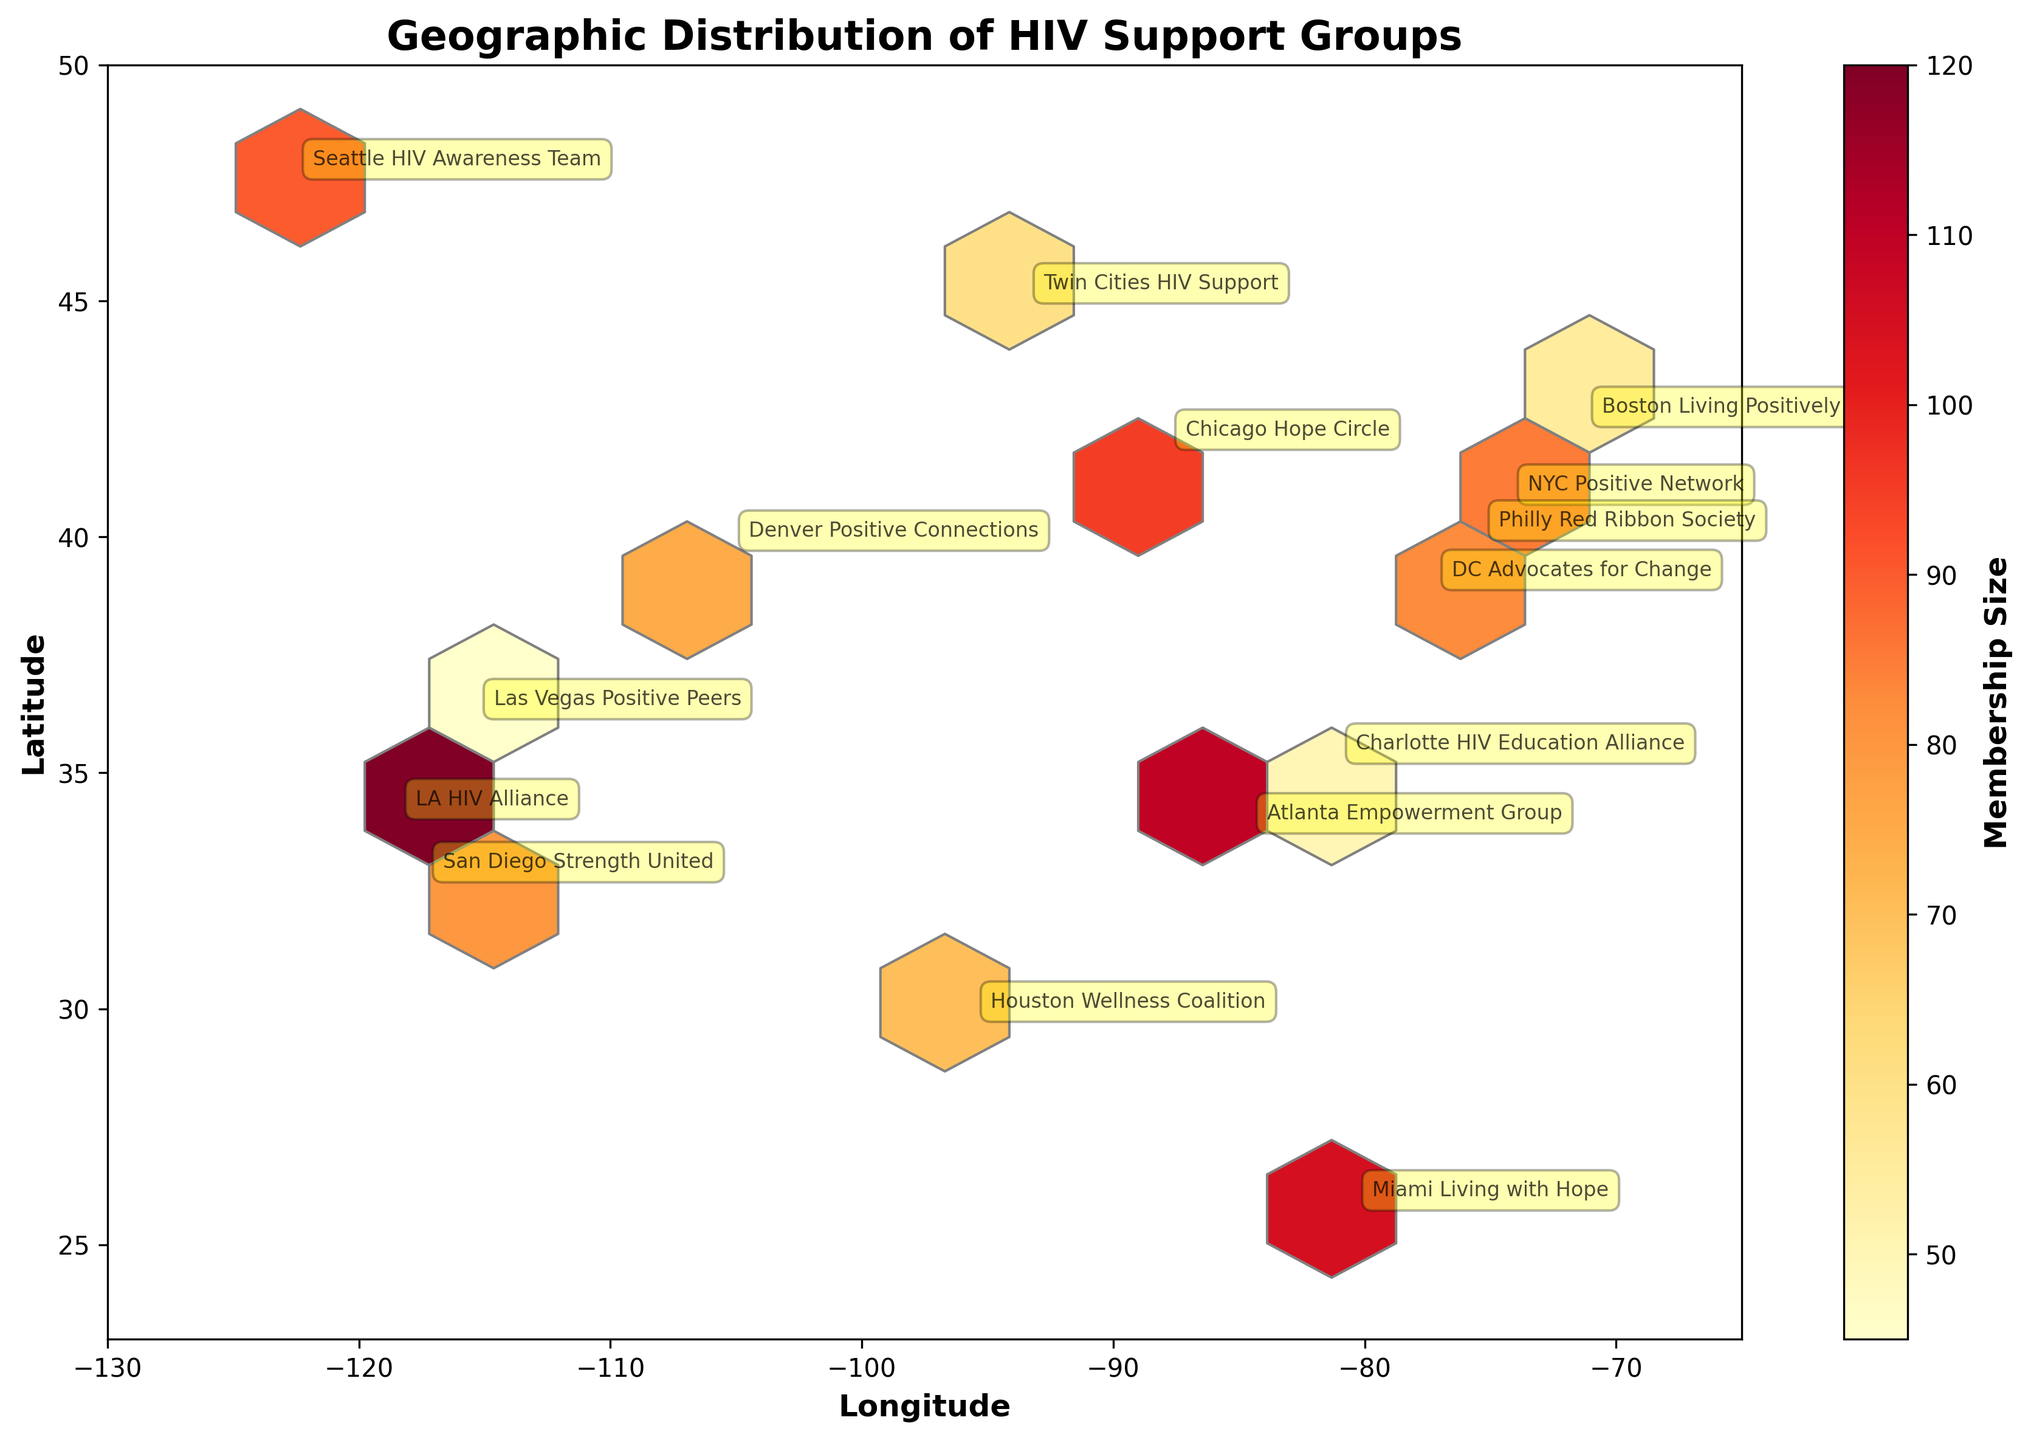What is the title of the plot? The title is prominently displayed at the top of the plot.
Answer: Geographic Distribution of HIV Support Groups Which support group has the largest membership size? The color intensity in the hexbin plot indicates the membership size, and the legend helps identify them. The LA HIV Alliance in Los Angeles has the largest membership size of 120.
Answer: LA HIV Alliance What longitude range is shown in the plot? The plot's x-axis represents longitude, and the range is defined by the axis limits.
Answer: -130 to -65 How many support groups are represented on the plot? Each annotated point represents a support group. By counting the annotations, we see that there are 15 groups shown.
Answer: 15 Which region appears to have the densest cluster of support groups? The density of support groups is indicated by darker and more frequent hexagonal bins. The northeastern region, particularly around New York and Philadelphia, shows the densest clustering.
Answer: Northeastern region What is the color scale used to indicate membership size? The color scale is shown in the color bar next to the plot. It ranges from yellow (smaller membership) to red (larger membership).
Answer: Yellow to red Which support group is located at the furthest northern latitude? By checking the annotations and latitudes, the Twin Cities HIV Support group in Minnesota is furthest north.
Answer: Twin Cities HIV Support What is the membership size range depicted in the plot? The membership size range is indicated by the color bar, which spans from the smallest membership size of 45 to the largest of 120.
Answer: 45 to 120 Is there a correlation between geographic location and membership size? By observing the hexbin plot, there is no clear linear pattern indicating a correlation between geographic location and membership size. Locations are scattered with varying membership sizes across the country.
Answer: No clear correlation How does the membership size of the Miami Living with Hope compare to the Boston Living Positively group? Miami's group has a membership size of 105, while Boston's group has 55 as seen from their annotation on the plot.
Answer: Miami's group is almost twice the size of Boston's group 